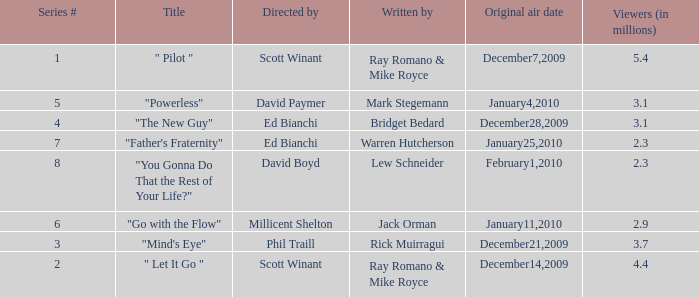How many episodes are written by Lew Schneider? 1.0. 